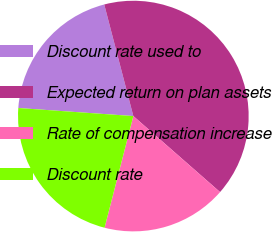<chart> <loc_0><loc_0><loc_500><loc_500><pie_chart><fcel>Discount rate used to<fcel>Expected return on plan assets<fcel>Rate of compensation increase<fcel>Discount rate<nl><fcel>19.83%<fcel>40.52%<fcel>17.56%<fcel>22.1%<nl></chart> 